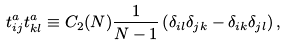Convert formula to latex. <formula><loc_0><loc_0><loc_500><loc_500>t ^ { a } _ { i j } t ^ { a } _ { k l } \equiv C _ { 2 } ( N ) \frac { 1 } { N - 1 } \left ( \delta _ { i l } \delta _ { j k } - \delta _ { i k } \delta _ { j l } \right ) ,</formula> 